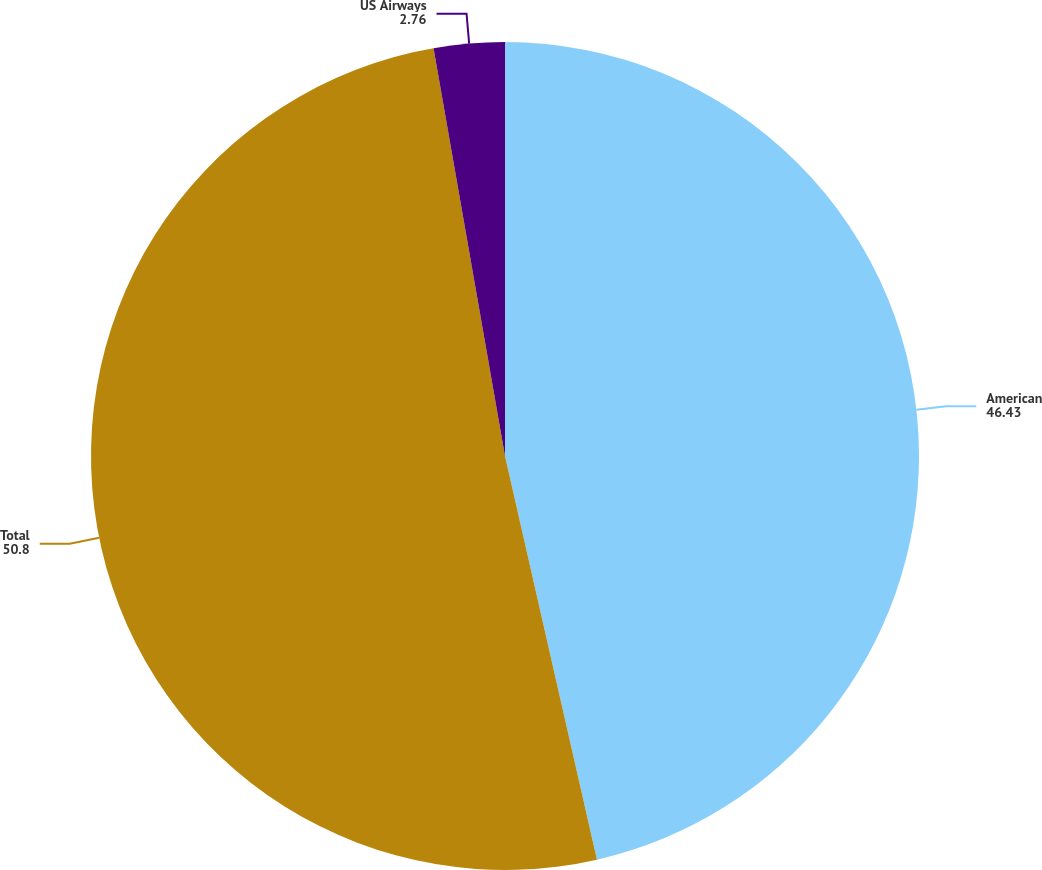Convert chart to OTSL. <chart><loc_0><loc_0><loc_500><loc_500><pie_chart><fcel>American<fcel>Total<fcel>US Airways<nl><fcel>46.43%<fcel>50.8%<fcel>2.76%<nl></chart> 